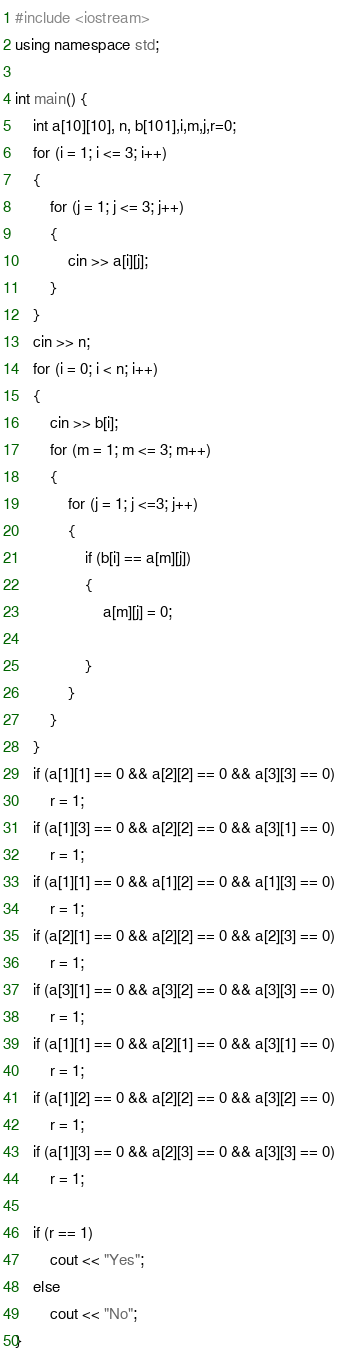<code> <loc_0><loc_0><loc_500><loc_500><_C++_>#include <iostream>
using namespace std;

int main() {
	int a[10][10], n, b[101],i,m,j,r=0;
	for (i = 1; i <= 3; i++)
	{
		for (j = 1; j <= 3; j++)
		{
			cin >> a[i][j];
		}
	}
	cin >> n;
	for (i = 0; i < n; i++)
	{
		cin >> b[i];
		for (m = 1; m <= 3; m++)
		{
			for (j = 1; j <=3; j++)
			{
				if (b[i] == a[m][j])
				{
					a[m][j] = 0;
				
				}
			}
		}
	}
	if (a[1][1] == 0 && a[2][2] == 0 && a[3][3] == 0)
		r = 1;
	if (a[1][3] == 0 && a[2][2] == 0 && a[3][1] == 0)
		r = 1;
	if (a[1][1] == 0 && a[1][2] == 0 && a[1][3] == 0)
		r = 1;
	if (a[2][1] == 0 && a[2][2] == 0 && a[2][3] == 0)
		r = 1;
	if (a[3][1] == 0 && a[3][2] == 0 && a[3][3] == 0)
		r = 1;
	if (a[1][1] == 0 && a[2][1] == 0 && a[3][1] == 0)
		r = 1;
	if (a[1][2] == 0 && a[2][2] == 0 && a[3][2] == 0)
		r = 1;
	if (a[1][3] == 0 && a[2][3] == 0 && a[3][3] == 0)
		r = 1;
	
	if (r == 1)
		cout << "Yes";
	else
		cout << "No";
}</code> 